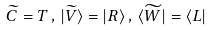<formula> <loc_0><loc_0><loc_500><loc_500>\widetilde { C } = T \, , \, | \widetilde { V } \rangle = | R \rangle \, , \, \langle \widetilde { W } | = \langle L |</formula> 